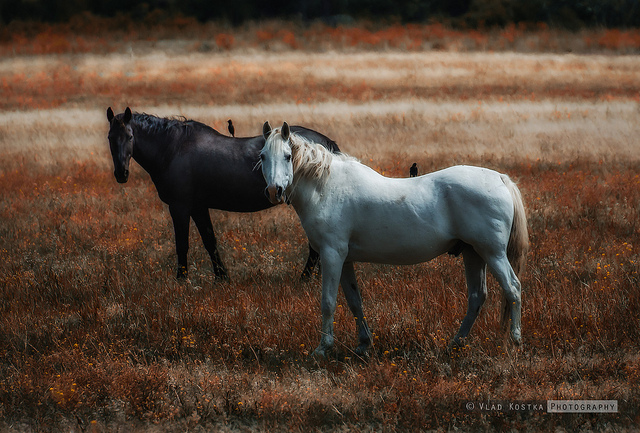Read all the text in this image. VLAD Kostka PHOTOGRAPHY 